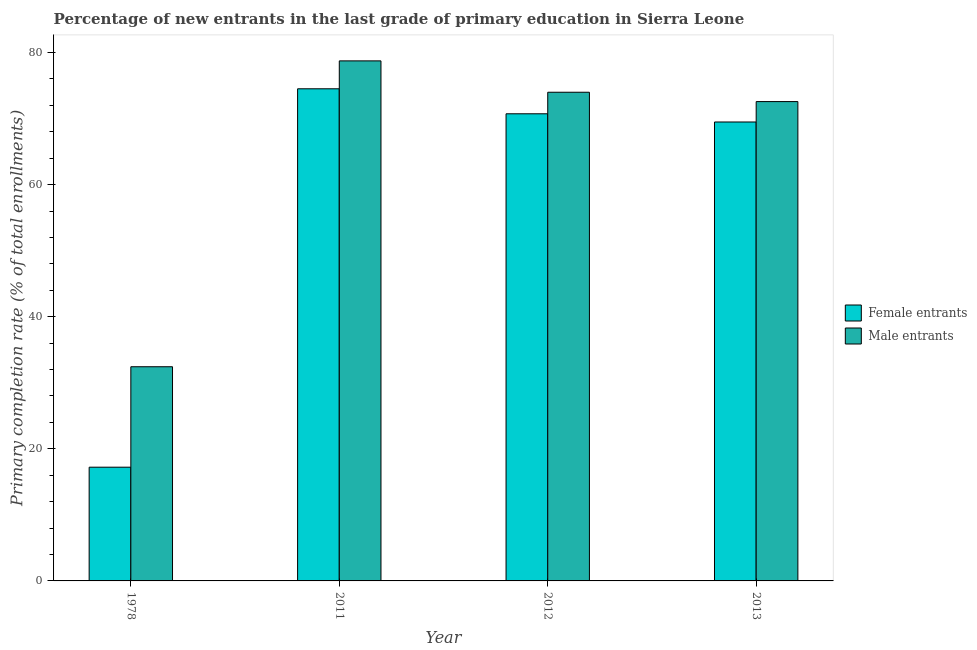How many groups of bars are there?
Offer a very short reply. 4. Are the number of bars per tick equal to the number of legend labels?
Provide a succinct answer. Yes. What is the primary completion rate of male entrants in 2011?
Your response must be concise. 78.74. Across all years, what is the maximum primary completion rate of male entrants?
Make the answer very short. 78.74. Across all years, what is the minimum primary completion rate of male entrants?
Offer a very short reply. 32.43. In which year was the primary completion rate of female entrants minimum?
Keep it short and to the point. 1978. What is the total primary completion rate of male entrants in the graph?
Offer a very short reply. 257.73. What is the difference between the primary completion rate of male entrants in 1978 and that in 2013?
Give a very brief answer. -40.14. What is the difference between the primary completion rate of male entrants in 1978 and the primary completion rate of female entrants in 2011?
Ensure brevity in your answer.  -46.31. What is the average primary completion rate of male entrants per year?
Keep it short and to the point. 64.43. What is the ratio of the primary completion rate of female entrants in 2011 to that in 2012?
Your answer should be very brief. 1.05. Is the difference between the primary completion rate of female entrants in 1978 and 2011 greater than the difference between the primary completion rate of male entrants in 1978 and 2011?
Offer a very short reply. No. What is the difference between the highest and the second highest primary completion rate of female entrants?
Make the answer very short. 3.79. What is the difference between the highest and the lowest primary completion rate of female entrants?
Your answer should be very brief. 57.29. Is the sum of the primary completion rate of male entrants in 2011 and 2012 greater than the maximum primary completion rate of female entrants across all years?
Provide a short and direct response. Yes. What does the 1st bar from the left in 2013 represents?
Your answer should be very brief. Female entrants. What does the 2nd bar from the right in 1978 represents?
Your response must be concise. Female entrants. How many bars are there?
Offer a terse response. 8. Are all the bars in the graph horizontal?
Make the answer very short. No. What is the difference between two consecutive major ticks on the Y-axis?
Ensure brevity in your answer.  20. Does the graph contain any zero values?
Make the answer very short. No. Does the graph contain grids?
Provide a short and direct response. No. Where does the legend appear in the graph?
Keep it short and to the point. Center right. How many legend labels are there?
Keep it short and to the point. 2. How are the legend labels stacked?
Your answer should be very brief. Vertical. What is the title of the graph?
Keep it short and to the point. Percentage of new entrants in the last grade of primary education in Sierra Leone. Does "Working only" appear as one of the legend labels in the graph?
Provide a short and direct response. No. What is the label or title of the Y-axis?
Your answer should be compact. Primary completion rate (% of total enrollments). What is the Primary completion rate (% of total enrollments) of Female entrants in 1978?
Keep it short and to the point. 17.22. What is the Primary completion rate (% of total enrollments) in Male entrants in 1978?
Provide a succinct answer. 32.43. What is the Primary completion rate (% of total enrollments) of Female entrants in 2011?
Offer a very short reply. 74.51. What is the Primary completion rate (% of total enrollments) of Male entrants in 2011?
Ensure brevity in your answer.  78.74. What is the Primary completion rate (% of total enrollments) of Female entrants in 2012?
Provide a short and direct response. 70.73. What is the Primary completion rate (% of total enrollments) of Male entrants in 2012?
Your response must be concise. 73.99. What is the Primary completion rate (% of total enrollments) in Female entrants in 2013?
Your response must be concise. 69.49. What is the Primary completion rate (% of total enrollments) of Male entrants in 2013?
Give a very brief answer. 72.57. Across all years, what is the maximum Primary completion rate (% of total enrollments) in Female entrants?
Offer a very short reply. 74.51. Across all years, what is the maximum Primary completion rate (% of total enrollments) in Male entrants?
Ensure brevity in your answer.  78.74. Across all years, what is the minimum Primary completion rate (% of total enrollments) in Female entrants?
Offer a very short reply. 17.22. Across all years, what is the minimum Primary completion rate (% of total enrollments) of Male entrants?
Your response must be concise. 32.43. What is the total Primary completion rate (% of total enrollments) in Female entrants in the graph?
Your answer should be very brief. 231.94. What is the total Primary completion rate (% of total enrollments) of Male entrants in the graph?
Ensure brevity in your answer.  257.73. What is the difference between the Primary completion rate (% of total enrollments) in Female entrants in 1978 and that in 2011?
Keep it short and to the point. -57.29. What is the difference between the Primary completion rate (% of total enrollments) in Male entrants in 1978 and that in 2011?
Offer a very short reply. -46.31. What is the difference between the Primary completion rate (% of total enrollments) in Female entrants in 1978 and that in 2012?
Make the answer very short. -53.51. What is the difference between the Primary completion rate (% of total enrollments) of Male entrants in 1978 and that in 2012?
Make the answer very short. -41.56. What is the difference between the Primary completion rate (% of total enrollments) in Female entrants in 1978 and that in 2013?
Offer a very short reply. -52.27. What is the difference between the Primary completion rate (% of total enrollments) of Male entrants in 1978 and that in 2013?
Keep it short and to the point. -40.14. What is the difference between the Primary completion rate (% of total enrollments) in Female entrants in 2011 and that in 2012?
Make the answer very short. 3.79. What is the difference between the Primary completion rate (% of total enrollments) of Male entrants in 2011 and that in 2012?
Make the answer very short. 4.75. What is the difference between the Primary completion rate (% of total enrollments) of Female entrants in 2011 and that in 2013?
Your answer should be compact. 5.03. What is the difference between the Primary completion rate (% of total enrollments) in Male entrants in 2011 and that in 2013?
Give a very brief answer. 6.16. What is the difference between the Primary completion rate (% of total enrollments) in Female entrants in 2012 and that in 2013?
Ensure brevity in your answer.  1.24. What is the difference between the Primary completion rate (% of total enrollments) of Male entrants in 2012 and that in 2013?
Offer a terse response. 1.42. What is the difference between the Primary completion rate (% of total enrollments) in Female entrants in 1978 and the Primary completion rate (% of total enrollments) in Male entrants in 2011?
Your answer should be compact. -61.52. What is the difference between the Primary completion rate (% of total enrollments) in Female entrants in 1978 and the Primary completion rate (% of total enrollments) in Male entrants in 2012?
Keep it short and to the point. -56.77. What is the difference between the Primary completion rate (% of total enrollments) in Female entrants in 1978 and the Primary completion rate (% of total enrollments) in Male entrants in 2013?
Your answer should be very brief. -55.35. What is the difference between the Primary completion rate (% of total enrollments) of Female entrants in 2011 and the Primary completion rate (% of total enrollments) of Male entrants in 2012?
Offer a terse response. 0.52. What is the difference between the Primary completion rate (% of total enrollments) of Female entrants in 2011 and the Primary completion rate (% of total enrollments) of Male entrants in 2013?
Your answer should be very brief. 1.94. What is the difference between the Primary completion rate (% of total enrollments) in Female entrants in 2012 and the Primary completion rate (% of total enrollments) in Male entrants in 2013?
Make the answer very short. -1.85. What is the average Primary completion rate (% of total enrollments) of Female entrants per year?
Provide a succinct answer. 57.99. What is the average Primary completion rate (% of total enrollments) of Male entrants per year?
Ensure brevity in your answer.  64.43. In the year 1978, what is the difference between the Primary completion rate (% of total enrollments) in Female entrants and Primary completion rate (% of total enrollments) in Male entrants?
Offer a terse response. -15.21. In the year 2011, what is the difference between the Primary completion rate (% of total enrollments) in Female entrants and Primary completion rate (% of total enrollments) in Male entrants?
Provide a succinct answer. -4.23. In the year 2012, what is the difference between the Primary completion rate (% of total enrollments) in Female entrants and Primary completion rate (% of total enrollments) in Male entrants?
Your answer should be very brief. -3.26. In the year 2013, what is the difference between the Primary completion rate (% of total enrollments) of Female entrants and Primary completion rate (% of total enrollments) of Male entrants?
Offer a very short reply. -3.09. What is the ratio of the Primary completion rate (% of total enrollments) in Female entrants in 1978 to that in 2011?
Offer a terse response. 0.23. What is the ratio of the Primary completion rate (% of total enrollments) of Male entrants in 1978 to that in 2011?
Keep it short and to the point. 0.41. What is the ratio of the Primary completion rate (% of total enrollments) in Female entrants in 1978 to that in 2012?
Provide a succinct answer. 0.24. What is the ratio of the Primary completion rate (% of total enrollments) of Male entrants in 1978 to that in 2012?
Provide a short and direct response. 0.44. What is the ratio of the Primary completion rate (% of total enrollments) of Female entrants in 1978 to that in 2013?
Keep it short and to the point. 0.25. What is the ratio of the Primary completion rate (% of total enrollments) in Male entrants in 1978 to that in 2013?
Keep it short and to the point. 0.45. What is the ratio of the Primary completion rate (% of total enrollments) of Female entrants in 2011 to that in 2012?
Keep it short and to the point. 1.05. What is the ratio of the Primary completion rate (% of total enrollments) in Male entrants in 2011 to that in 2012?
Offer a terse response. 1.06. What is the ratio of the Primary completion rate (% of total enrollments) of Female entrants in 2011 to that in 2013?
Ensure brevity in your answer.  1.07. What is the ratio of the Primary completion rate (% of total enrollments) in Male entrants in 2011 to that in 2013?
Give a very brief answer. 1.08. What is the ratio of the Primary completion rate (% of total enrollments) of Female entrants in 2012 to that in 2013?
Ensure brevity in your answer.  1.02. What is the ratio of the Primary completion rate (% of total enrollments) in Male entrants in 2012 to that in 2013?
Your answer should be very brief. 1.02. What is the difference between the highest and the second highest Primary completion rate (% of total enrollments) of Female entrants?
Your answer should be very brief. 3.79. What is the difference between the highest and the second highest Primary completion rate (% of total enrollments) in Male entrants?
Make the answer very short. 4.75. What is the difference between the highest and the lowest Primary completion rate (% of total enrollments) in Female entrants?
Your answer should be very brief. 57.29. What is the difference between the highest and the lowest Primary completion rate (% of total enrollments) of Male entrants?
Make the answer very short. 46.31. 